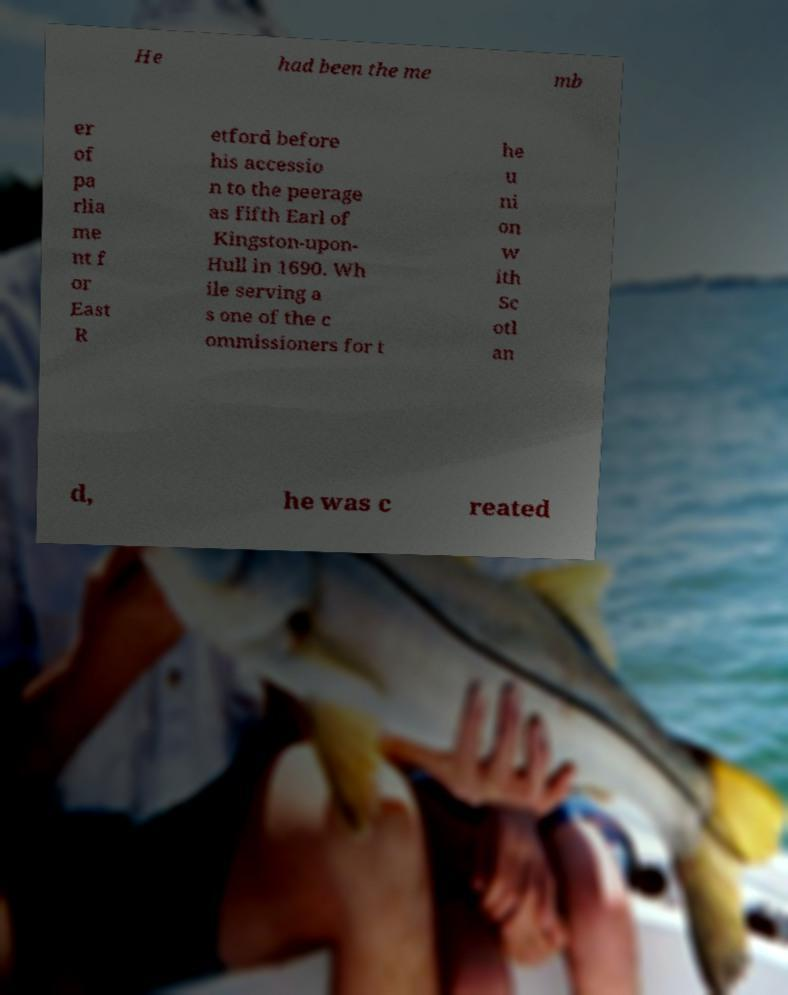For documentation purposes, I need the text within this image transcribed. Could you provide that? He had been the me mb er of pa rlia me nt f or East R etford before his accessio n to the peerage as fifth Earl of Kingston-upon- Hull in 1690. Wh ile serving a s one of the c ommissioners for t he u ni on w ith Sc otl an d, he was c reated 